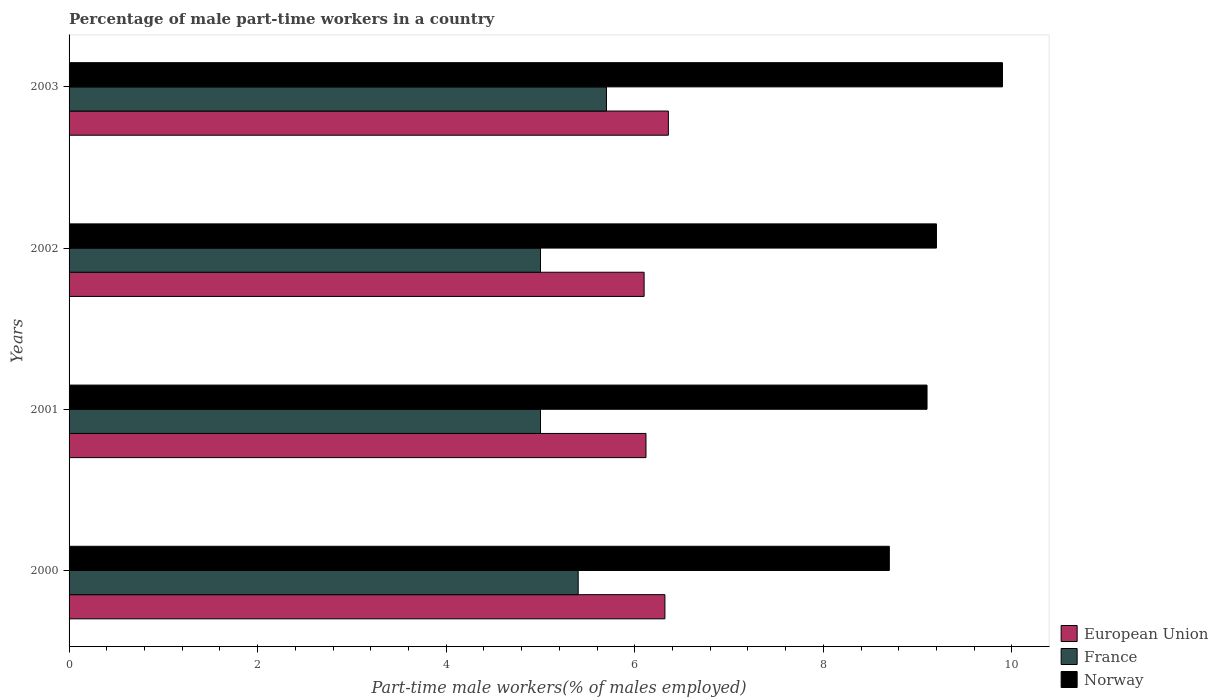How many different coloured bars are there?
Give a very brief answer. 3. Are the number of bars per tick equal to the number of legend labels?
Your response must be concise. Yes. Are the number of bars on each tick of the Y-axis equal?
Your answer should be very brief. Yes. How many bars are there on the 3rd tick from the bottom?
Provide a short and direct response. 3. In how many cases, is the number of bars for a given year not equal to the number of legend labels?
Make the answer very short. 0. What is the percentage of male part-time workers in Norway in 2001?
Offer a terse response. 9.1. Across all years, what is the maximum percentage of male part-time workers in European Union?
Provide a short and direct response. 6.36. Across all years, what is the minimum percentage of male part-time workers in European Union?
Provide a short and direct response. 6.1. In which year was the percentage of male part-time workers in European Union maximum?
Provide a short and direct response. 2003. What is the total percentage of male part-time workers in Norway in the graph?
Your answer should be very brief. 36.9. What is the difference between the percentage of male part-time workers in Norway in 2000 and that in 2002?
Your answer should be compact. -0.5. What is the difference between the percentage of male part-time workers in European Union in 2000 and the percentage of male part-time workers in Norway in 2001?
Offer a terse response. -2.78. What is the average percentage of male part-time workers in France per year?
Your answer should be compact. 5.27. In the year 2000, what is the difference between the percentage of male part-time workers in France and percentage of male part-time workers in European Union?
Offer a terse response. -0.92. What is the ratio of the percentage of male part-time workers in Norway in 2002 to that in 2003?
Offer a terse response. 0.93. Is the percentage of male part-time workers in European Union in 2002 less than that in 2003?
Ensure brevity in your answer.  Yes. What is the difference between the highest and the second highest percentage of male part-time workers in Norway?
Your answer should be very brief. 0.7. What is the difference between the highest and the lowest percentage of male part-time workers in Norway?
Provide a short and direct response. 1.2. In how many years, is the percentage of male part-time workers in Norway greater than the average percentage of male part-time workers in Norway taken over all years?
Keep it short and to the point. 1. Is the sum of the percentage of male part-time workers in Norway in 2000 and 2003 greater than the maximum percentage of male part-time workers in European Union across all years?
Ensure brevity in your answer.  Yes. What does the 3rd bar from the top in 2000 represents?
Your answer should be very brief. European Union. What does the 2nd bar from the bottom in 2000 represents?
Make the answer very short. France. What is the difference between two consecutive major ticks on the X-axis?
Give a very brief answer. 2. Does the graph contain grids?
Your response must be concise. No. Where does the legend appear in the graph?
Ensure brevity in your answer.  Bottom right. How many legend labels are there?
Offer a very short reply. 3. How are the legend labels stacked?
Keep it short and to the point. Vertical. What is the title of the graph?
Your answer should be very brief. Percentage of male part-time workers in a country. Does "Maldives" appear as one of the legend labels in the graph?
Your answer should be very brief. No. What is the label or title of the X-axis?
Your answer should be compact. Part-time male workers(% of males employed). What is the label or title of the Y-axis?
Offer a very short reply. Years. What is the Part-time male workers(% of males employed) of European Union in 2000?
Keep it short and to the point. 6.32. What is the Part-time male workers(% of males employed) of France in 2000?
Your response must be concise. 5.4. What is the Part-time male workers(% of males employed) of Norway in 2000?
Give a very brief answer. 8.7. What is the Part-time male workers(% of males employed) in European Union in 2001?
Give a very brief answer. 6.12. What is the Part-time male workers(% of males employed) of France in 2001?
Your response must be concise. 5. What is the Part-time male workers(% of males employed) in Norway in 2001?
Offer a terse response. 9.1. What is the Part-time male workers(% of males employed) of European Union in 2002?
Provide a succinct answer. 6.1. What is the Part-time male workers(% of males employed) in Norway in 2002?
Provide a short and direct response. 9.2. What is the Part-time male workers(% of males employed) in European Union in 2003?
Provide a succinct answer. 6.36. What is the Part-time male workers(% of males employed) in France in 2003?
Your response must be concise. 5.7. What is the Part-time male workers(% of males employed) in Norway in 2003?
Provide a succinct answer. 9.9. Across all years, what is the maximum Part-time male workers(% of males employed) in European Union?
Your response must be concise. 6.36. Across all years, what is the maximum Part-time male workers(% of males employed) in France?
Your response must be concise. 5.7. Across all years, what is the maximum Part-time male workers(% of males employed) in Norway?
Ensure brevity in your answer.  9.9. Across all years, what is the minimum Part-time male workers(% of males employed) of European Union?
Keep it short and to the point. 6.1. Across all years, what is the minimum Part-time male workers(% of males employed) in Norway?
Ensure brevity in your answer.  8.7. What is the total Part-time male workers(% of males employed) in European Union in the graph?
Ensure brevity in your answer.  24.89. What is the total Part-time male workers(% of males employed) of France in the graph?
Offer a terse response. 21.1. What is the total Part-time male workers(% of males employed) in Norway in the graph?
Provide a succinct answer. 36.9. What is the difference between the Part-time male workers(% of males employed) in European Union in 2000 and that in 2001?
Offer a terse response. 0.2. What is the difference between the Part-time male workers(% of males employed) of France in 2000 and that in 2001?
Provide a short and direct response. 0.4. What is the difference between the Part-time male workers(% of males employed) in Norway in 2000 and that in 2001?
Provide a succinct answer. -0.4. What is the difference between the Part-time male workers(% of males employed) of European Union in 2000 and that in 2002?
Your response must be concise. 0.22. What is the difference between the Part-time male workers(% of males employed) of France in 2000 and that in 2002?
Ensure brevity in your answer.  0.4. What is the difference between the Part-time male workers(% of males employed) of European Union in 2000 and that in 2003?
Provide a short and direct response. -0.04. What is the difference between the Part-time male workers(% of males employed) in Norway in 2000 and that in 2003?
Offer a terse response. -1.2. What is the difference between the Part-time male workers(% of males employed) of European Union in 2001 and that in 2002?
Your answer should be compact. 0.02. What is the difference between the Part-time male workers(% of males employed) in France in 2001 and that in 2002?
Your answer should be very brief. 0. What is the difference between the Part-time male workers(% of males employed) in Norway in 2001 and that in 2002?
Offer a very short reply. -0.1. What is the difference between the Part-time male workers(% of males employed) in European Union in 2001 and that in 2003?
Keep it short and to the point. -0.24. What is the difference between the Part-time male workers(% of males employed) of Norway in 2001 and that in 2003?
Your answer should be compact. -0.8. What is the difference between the Part-time male workers(% of males employed) in European Union in 2002 and that in 2003?
Provide a succinct answer. -0.26. What is the difference between the Part-time male workers(% of males employed) in France in 2002 and that in 2003?
Give a very brief answer. -0.7. What is the difference between the Part-time male workers(% of males employed) of European Union in 2000 and the Part-time male workers(% of males employed) of France in 2001?
Make the answer very short. 1.32. What is the difference between the Part-time male workers(% of males employed) of European Union in 2000 and the Part-time male workers(% of males employed) of Norway in 2001?
Provide a short and direct response. -2.78. What is the difference between the Part-time male workers(% of males employed) of European Union in 2000 and the Part-time male workers(% of males employed) of France in 2002?
Provide a succinct answer. 1.32. What is the difference between the Part-time male workers(% of males employed) of European Union in 2000 and the Part-time male workers(% of males employed) of Norway in 2002?
Provide a short and direct response. -2.88. What is the difference between the Part-time male workers(% of males employed) of European Union in 2000 and the Part-time male workers(% of males employed) of France in 2003?
Keep it short and to the point. 0.62. What is the difference between the Part-time male workers(% of males employed) in European Union in 2000 and the Part-time male workers(% of males employed) in Norway in 2003?
Ensure brevity in your answer.  -3.58. What is the difference between the Part-time male workers(% of males employed) in European Union in 2001 and the Part-time male workers(% of males employed) in France in 2002?
Your answer should be very brief. 1.12. What is the difference between the Part-time male workers(% of males employed) of European Union in 2001 and the Part-time male workers(% of males employed) of Norway in 2002?
Offer a terse response. -3.08. What is the difference between the Part-time male workers(% of males employed) in European Union in 2001 and the Part-time male workers(% of males employed) in France in 2003?
Your answer should be compact. 0.42. What is the difference between the Part-time male workers(% of males employed) in European Union in 2001 and the Part-time male workers(% of males employed) in Norway in 2003?
Offer a terse response. -3.78. What is the difference between the Part-time male workers(% of males employed) in France in 2001 and the Part-time male workers(% of males employed) in Norway in 2003?
Make the answer very short. -4.9. What is the difference between the Part-time male workers(% of males employed) of European Union in 2002 and the Part-time male workers(% of males employed) of France in 2003?
Ensure brevity in your answer.  0.4. What is the difference between the Part-time male workers(% of males employed) of European Union in 2002 and the Part-time male workers(% of males employed) of Norway in 2003?
Ensure brevity in your answer.  -3.8. What is the difference between the Part-time male workers(% of males employed) of France in 2002 and the Part-time male workers(% of males employed) of Norway in 2003?
Your response must be concise. -4.9. What is the average Part-time male workers(% of males employed) in European Union per year?
Keep it short and to the point. 6.22. What is the average Part-time male workers(% of males employed) of France per year?
Make the answer very short. 5.28. What is the average Part-time male workers(% of males employed) of Norway per year?
Keep it short and to the point. 9.22. In the year 2000, what is the difference between the Part-time male workers(% of males employed) in European Union and Part-time male workers(% of males employed) in France?
Your response must be concise. 0.92. In the year 2000, what is the difference between the Part-time male workers(% of males employed) in European Union and Part-time male workers(% of males employed) in Norway?
Offer a terse response. -2.38. In the year 2000, what is the difference between the Part-time male workers(% of males employed) of France and Part-time male workers(% of males employed) of Norway?
Your answer should be compact. -3.3. In the year 2001, what is the difference between the Part-time male workers(% of males employed) in European Union and Part-time male workers(% of males employed) in France?
Your answer should be compact. 1.12. In the year 2001, what is the difference between the Part-time male workers(% of males employed) in European Union and Part-time male workers(% of males employed) in Norway?
Ensure brevity in your answer.  -2.98. In the year 2001, what is the difference between the Part-time male workers(% of males employed) of France and Part-time male workers(% of males employed) of Norway?
Your answer should be very brief. -4.1. In the year 2002, what is the difference between the Part-time male workers(% of males employed) in European Union and Part-time male workers(% of males employed) in France?
Your response must be concise. 1.1. In the year 2002, what is the difference between the Part-time male workers(% of males employed) in European Union and Part-time male workers(% of males employed) in Norway?
Your response must be concise. -3.1. In the year 2002, what is the difference between the Part-time male workers(% of males employed) in France and Part-time male workers(% of males employed) in Norway?
Your answer should be very brief. -4.2. In the year 2003, what is the difference between the Part-time male workers(% of males employed) in European Union and Part-time male workers(% of males employed) in France?
Offer a very short reply. 0.66. In the year 2003, what is the difference between the Part-time male workers(% of males employed) in European Union and Part-time male workers(% of males employed) in Norway?
Offer a terse response. -3.54. What is the ratio of the Part-time male workers(% of males employed) in European Union in 2000 to that in 2001?
Offer a terse response. 1.03. What is the ratio of the Part-time male workers(% of males employed) in France in 2000 to that in 2001?
Ensure brevity in your answer.  1.08. What is the ratio of the Part-time male workers(% of males employed) in Norway in 2000 to that in 2001?
Ensure brevity in your answer.  0.96. What is the ratio of the Part-time male workers(% of males employed) of European Union in 2000 to that in 2002?
Your answer should be compact. 1.04. What is the ratio of the Part-time male workers(% of males employed) in France in 2000 to that in 2002?
Provide a succinct answer. 1.08. What is the ratio of the Part-time male workers(% of males employed) of Norway in 2000 to that in 2002?
Make the answer very short. 0.95. What is the ratio of the Part-time male workers(% of males employed) in France in 2000 to that in 2003?
Provide a succinct answer. 0.95. What is the ratio of the Part-time male workers(% of males employed) of Norway in 2000 to that in 2003?
Give a very brief answer. 0.88. What is the ratio of the Part-time male workers(% of males employed) in France in 2001 to that in 2002?
Your response must be concise. 1. What is the ratio of the Part-time male workers(% of males employed) of European Union in 2001 to that in 2003?
Provide a short and direct response. 0.96. What is the ratio of the Part-time male workers(% of males employed) in France in 2001 to that in 2003?
Offer a very short reply. 0.88. What is the ratio of the Part-time male workers(% of males employed) in Norway in 2001 to that in 2003?
Offer a very short reply. 0.92. What is the ratio of the Part-time male workers(% of males employed) in European Union in 2002 to that in 2003?
Make the answer very short. 0.96. What is the ratio of the Part-time male workers(% of males employed) in France in 2002 to that in 2003?
Offer a terse response. 0.88. What is the ratio of the Part-time male workers(% of males employed) of Norway in 2002 to that in 2003?
Provide a succinct answer. 0.93. What is the difference between the highest and the second highest Part-time male workers(% of males employed) of European Union?
Make the answer very short. 0.04. What is the difference between the highest and the second highest Part-time male workers(% of males employed) of France?
Your answer should be very brief. 0.3. What is the difference between the highest and the second highest Part-time male workers(% of males employed) of Norway?
Make the answer very short. 0.7. What is the difference between the highest and the lowest Part-time male workers(% of males employed) of European Union?
Give a very brief answer. 0.26. What is the difference between the highest and the lowest Part-time male workers(% of males employed) in France?
Offer a terse response. 0.7. 